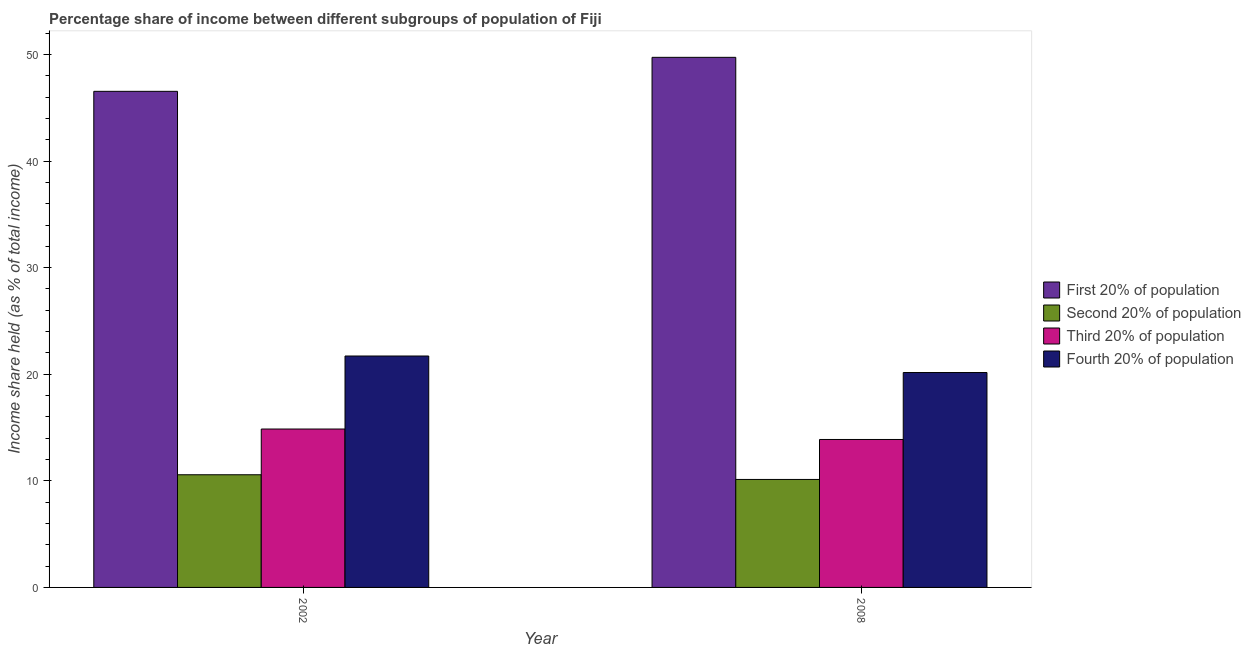How many bars are there on the 2nd tick from the left?
Make the answer very short. 4. In how many cases, is the number of bars for a given year not equal to the number of legend labels?
Give a very brief answer. 0. What is the share of the income held by second 20% of the population in 2002?
Provide a short and direct response. 10.57. Across all years, what is the maximum share of the income held by first 20% of the population?
Your response must be concise. 49.73. Across all years, what is the minimum share of the income held by second 20% of the population?
Your response must be concise. 10.13. In which year was the share of the income held by first 20% of the population minimum?
Offer a very short reply. 2002. What is the total share of the income held by third 20% of the population in the graph?
Offer a terse response. 28.74. What is the difference between the share of the income held by third 20% of the population in 2002 and that in 2008?
Give a very brief answer. 0.98. What is the difference between the share of the income held by first 20% of the population in 2008 and the share of the income held by fourth 20% of the population in 2002?
Provide a succinct answer. 3.19. What is the average share of the income held by third 20% of the population per year?
Your answer should be very brief. 14.37. What is the ratio of the share of the income held by first 20% of the population in 2002 to that in 2008?
Provide a short and direct response. 0.94. In how many years, is the share of the income held by third 20% of the population greater than the average share of the income held by third 20% of the population taken over all years?
Provide a short and direct response. 1. What does the 3rd bar from the left in 2002 represents?
Offer a very short reply. Third 20% of population. What does the 4th bar from the right in 2008 represents?
Offer a very short reply. First 20% of population. Are all the bars in the graph horizontal?
Your answer should be compact. No. What is the difference between two consecutive major ticks on the Y-axis?
Give a very brief answer. 10. Are the values on the major ticks of Y-axis written in scientific E-notation?
Your answer should be very brief. No. Does the graph contain any zero values?
Your response must be concise. No. Where does the legend appear in the graph?
Provide a short and direct response. Center right. How many legend labels are there?
Provide a short and direct response. 4. How are the legend labels stacked?
Offer a very short reply. Vertical. What is the title of the graph?
Give a very brief answer. Percentage share of income between different subgroups of population of Fiji. What is the label or title of the X-axis?
Your answer should be compact. Year. What is the label or title of the Y-axis?
Your response must be concise. Income share held (as % of total income). What is the Income share held (as % of total income) in First 20% of population in 2002?
Provide a succinct answer. 46.54. What is the Income share held (as % of total income) of Second 20% of population in 2002?
Your answer should be compact. 10.57. What is the Income share held (as % of total income) in Third 20% of population in 2002?
Ensure brevity in your answer.  14.86. What is the Income share held (as % of total income) of Fourth 20% of population in 2002?
Your answer should be compact. 21.71. What is the Income share held (as % of total income) of First 20% of population in 2008?
Your answer should be very brief. 49.73. What is the Income share held (as % of total income) in Second 20% of population in 2008?
Provide a short and direct response. 10.13. What is the Income share held (as % of total income) of Third 20% of population in 2008?
Your answer should be very brief. 13.88. What is the Income share held (as % of total income) in Fourth 20% of population in 2008?
Keep it short and to the point. 20.16. Across all years, what is the maximum Income share held (as % of total income) of First 20% of population?
Make the answer very short. 49.73. Across all years, what is the maximum Income share held (as % of total income) in Second 20% of population?
Provide a succinct answer. 10.57. Across all years, what is the maximum Income share held (as % of total income) of Third 20% of population?
Your response must be concise. 14.86. Across all years, what is the maximum Income share held (as % of total income) of Fourth 20% of population?
Offer a very short reply. 21.71. Across all years, what is the minimum Income share held (as % of total income) of First 20% of population?
Give a very brief answer. 46.54. Across all years, what is the minimum Income share held (as % of total income) in Second 20% of population?
Provide a short and direct response. 10.13. Across all years, what is the minimum Income share held (as % of total income) of Third 20% of population?
Make the answer very short. 13.88. Across all years, what is the minimum Income share held (as % of total income) in Fourth 20% of population?
Make the answer very short. 20.16. What is the total Income share held (as % of total income) in First 20% of population in the graph?
Your answer should be very brief. 96.27. What is the total Income share held (as % of total income) in Second 20% of population in the graph?
Your response must be concise. 20.7. What is the total Income share held (as % of total income) in Third 20% of population in the graph?
Offer a terse response. 28.74. What is the total Income share held (as % of total income) in Fourth 20% of population in the graph?
Ensure brevity in your answer.  41.87. What is the difference between the Income share held (as % of total income) of First 20% of population in 2002 and that in 2008?
Your answer should be very brief. -3.19. What is the difference between the Income share held (as % of total income) in Second 20% of population in 2002 and that in 2008?
Provide a short and direct response. 0.44. What is the difference between the Income share held (as % of total income) in Fourth 20% of population in 2002 and that in 2008?
Offer a terse response. 1.55. What is the difference between the Income share held (as % of total income) in First 20% of population in 2002 and the Income share held (as % of total income) in Second 20% of population in 2008?
Keep it short and to the point. 36.41. What is the difference between the Income share held (as % of total income) of First 20% of population in 2002 and the Income share held (as % of total income) of Third 20% of population in 2008?
Your answer should be compact. 32.66. What is the difference between the Income share held (as % of total income) in First 20% of population in 2002 and the Income share held (as % of total income) in Fourth 20% of population in 2008?
Provide a short and direct response. 26.38. What is the difference between the Income share held (as % of total income) of Second 20% of population in 2002 and the Income share held (as % of total income) of Third 20% of population in 2008?
Provide a succinct answer. -3.31. What is the difference between the Income share held (as % of total income) in Second 20% of population in 2002 and the Income share held (as % of total income) in Fourth 20% of population in 2008?
Offer a terse response. -9.59. What is the difference between the Income share held (as % of total income) of Third 20% of population in 2002 and the Income share held (as % of total income) of Fourth 20% of population in 2008?
Give a very brief answer. -5.3. What is the average Income share held (as % of total income) in First 20% of population per year?
Offer a very short reply. 48.13. What is the average Income share held (as % of total income) of Second 20% of population per year?
Give a very brief answer. 10.35. What is the average Income share held (as % of total income) in Third 20% of population per year?
Provide a short and direct response. 14.37. What is the average Income share held (as % of total income) in Fourth 20% of population per year?
Provide a succinct answer. 20.93. In the year 2002, what is the difference between the Income share held (as % of total income) of First 20% of population and Income share held (as % of total income) of Second 20% of population?
Your answer should be very brief. 35.97. In the year 2002, what is the difference between the Income share held (as % of total income) in First 20% of population and Income share held (as % of total income) in Third 20% of population?
Your answer should be compact. 31.68. In the year 2002, what is the difference between the Income share held (as % of total income) in First 20% of population and Income share held (as % of total income) in Fourth 20% of population?
Offer a very short reply. 24.83. In the year 2002, what is the difference between the Income share held (as % of total income) in Second 20% of population and Income share held (as % of total income) in Third 20% of population?
Your response must be concise. -4.29. In the year 2002, what is the difference between the Income share held (as % of total income) of Second 20% of population and Income share held (as % of total income) of Fourth 20% of population?
Give a very brief answer. -11.14. In the year 2002, what is the difference between the Income share held (as % of total income) in Third 20% of population and Income share held (as % of total income) in Fourth 20% of population?
Ensure brevity in your answer.  -6.85. In the year 2008, what is the difference between the Income share held (as % of total income) of First 20% of population and Income share held (as % of total income) of Second 20% of population?
Offer a terse response. 39.6. In the year 2008, what is the difference between the Income share held (as % of total income) in First 20% of population and Income share held (as % of total income) in Third 20% of population?
Provide a short and direct response. 35.85. In the year 2008, what is the difference between the Income share held (as % of total income) of First 20% of population and Income share held (as % of total income) of Fourth 20% of population?
Offer a terse response. 29.57. In the year 2008, what is the difference between the Income share held (as % of total income) in Second 20% of population and Income share held (as % of total income) in Third 20% of population?
Give a very brief answer. -3.75. In the year 2008, what is the difference between the Income share held (as % of total income) of Second 20% of population and Income share held (as % of total income) of Fourth 20% of population?
Ensure brevity in your answer.  -10.03. In the year 2008, what is the difference between the Income share held (as % of total income) of Third 20% of population and Income share held (as % of total income) of Fourth 20% of population?
Make the answer very short. -6.28. What is the ratio of the Income share held (as % of total income) of First 20% of population in 2002 to that in 2008?
Give a very brief answer. 0.94. What is the ratio of the Income share held (as % of total income) in Second 20% of population in 2002 to that in 2008?
Ensure brevity in your answer.  1.04. What is the ratio of the Income share held (as % of total income) of Third 20% of population in 2002 to that in 2008?
Your answer should be very brief. 1.07. What is the difference between the highest and the second highest Income share held (as % of total income) in First 20% of population?
Make the answer very short. 3.19. What is the difference between the highest and the second highest Income share held (as % of total income) in Second 20% of population?
Offer a terse response. 0.44. What is the difference between the highest and the second highest Income share held (as % of total income) of Fourth 20% of population?
Provide a succinct answer. 1.55. What is the difference between the highest and the lowest Income share held (as % of total income) of First 20% of population?
Keep it short and to the point. 3.19. What is the difference between the highest and the lowest Income share held (as % of total income) of Second 20% of population?
Your answer should be compact. 0.44. What is the difference between the highest and the lowest Income share held (as % of total income) of Fourth 20% of population?
Make the answer very short. 1.55. 